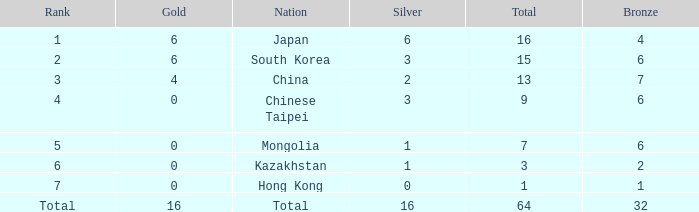Which Silver has a Nation of china, and a Bronze smaller than 7? None. 